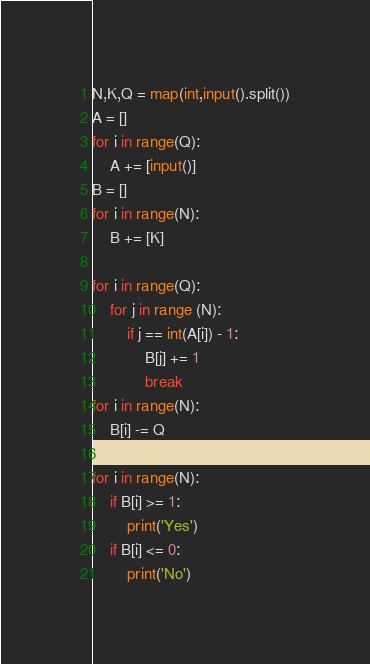Convert code to text. <code><loc_0><loc_0><loc_500><loc_500><_Python_>N,K,Q = map(int,input().split())
A = []
for i in range(Q):
    A += [input()]
B = []
for i in range(N):
    B += [K]
    
for i in range(Q):
    for j in range (N):
        if j == int(A[i]) - 1:
            B[j] += 1
            break
for i in range(N):
    B[i] -= Q
    
for i in range(N):
    if B[i] >= 1:
        print('Yes')
    if B[i] <= 0:
        print('No')





</code> 